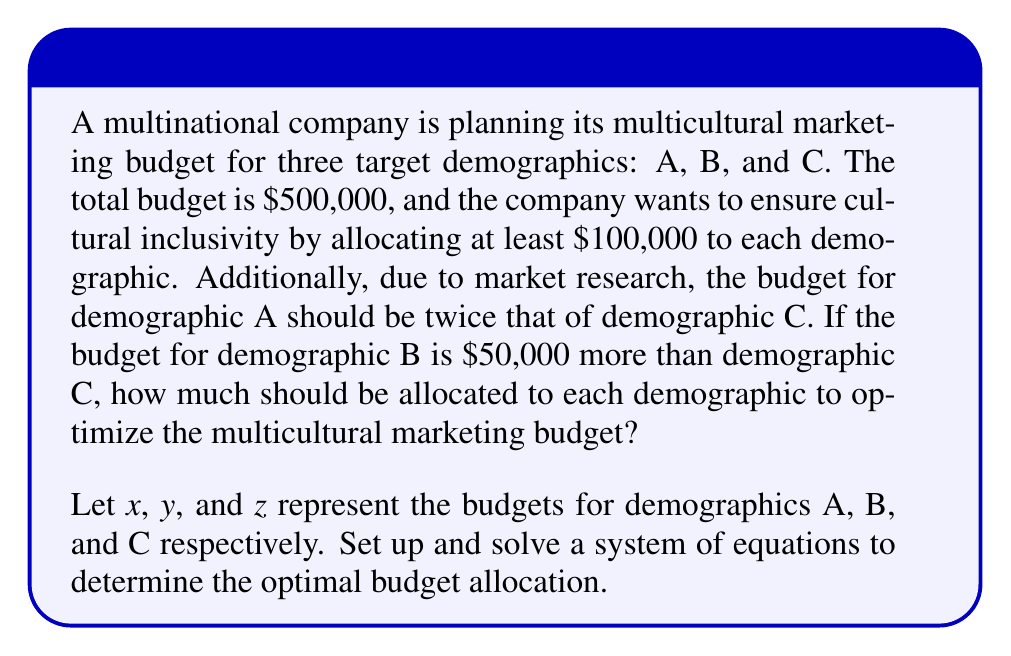Teach me how to tackle this problem. Let's approach this step-by-step:

1) First, let's define our variables:
   $x$ = budget for demographic A
   $y$ = budget for demographic B
   $z$ = budget for demographic C

2) Now, let's set up our system of equations based on the given information:

   Equation 1: Total budget
   $$x + y + z = 500,000$$

   Equation 2: A's budget is twice C's
   $$x = 2z$$

   Equation 3: B's budget is $50,000 more than C's
   $$y = z + 50,000$$

3) Substitute Equations 2 and 3 into Equation 1:
   $$(2z) + (z + 50,000) + z = 500,000$$

4) Simplify:
   $$4z + 50,000 = 500,000$$

5) Solve for z:
   $$4z = 450,000$$
   $$z = 112,500$$

6) Now we can find x and y:
   $$x = 2z = 2(112,500) = 225,000$$
   $$y = z + 50,000 = 112,500 + 50,000 = 162,500$$

7) Verify that each demographic gets at least $100,000 and the total is $500,000:
   $$225,000 + 162,500 + 112,500 = 500,000$$

Therefore, the optimal budget allocation is:
Demographic A: $225,000
Demographic B: $162,500
Demographic C: $112,500
Answer: A: $225,000, B: $162,500, C: $112,500 